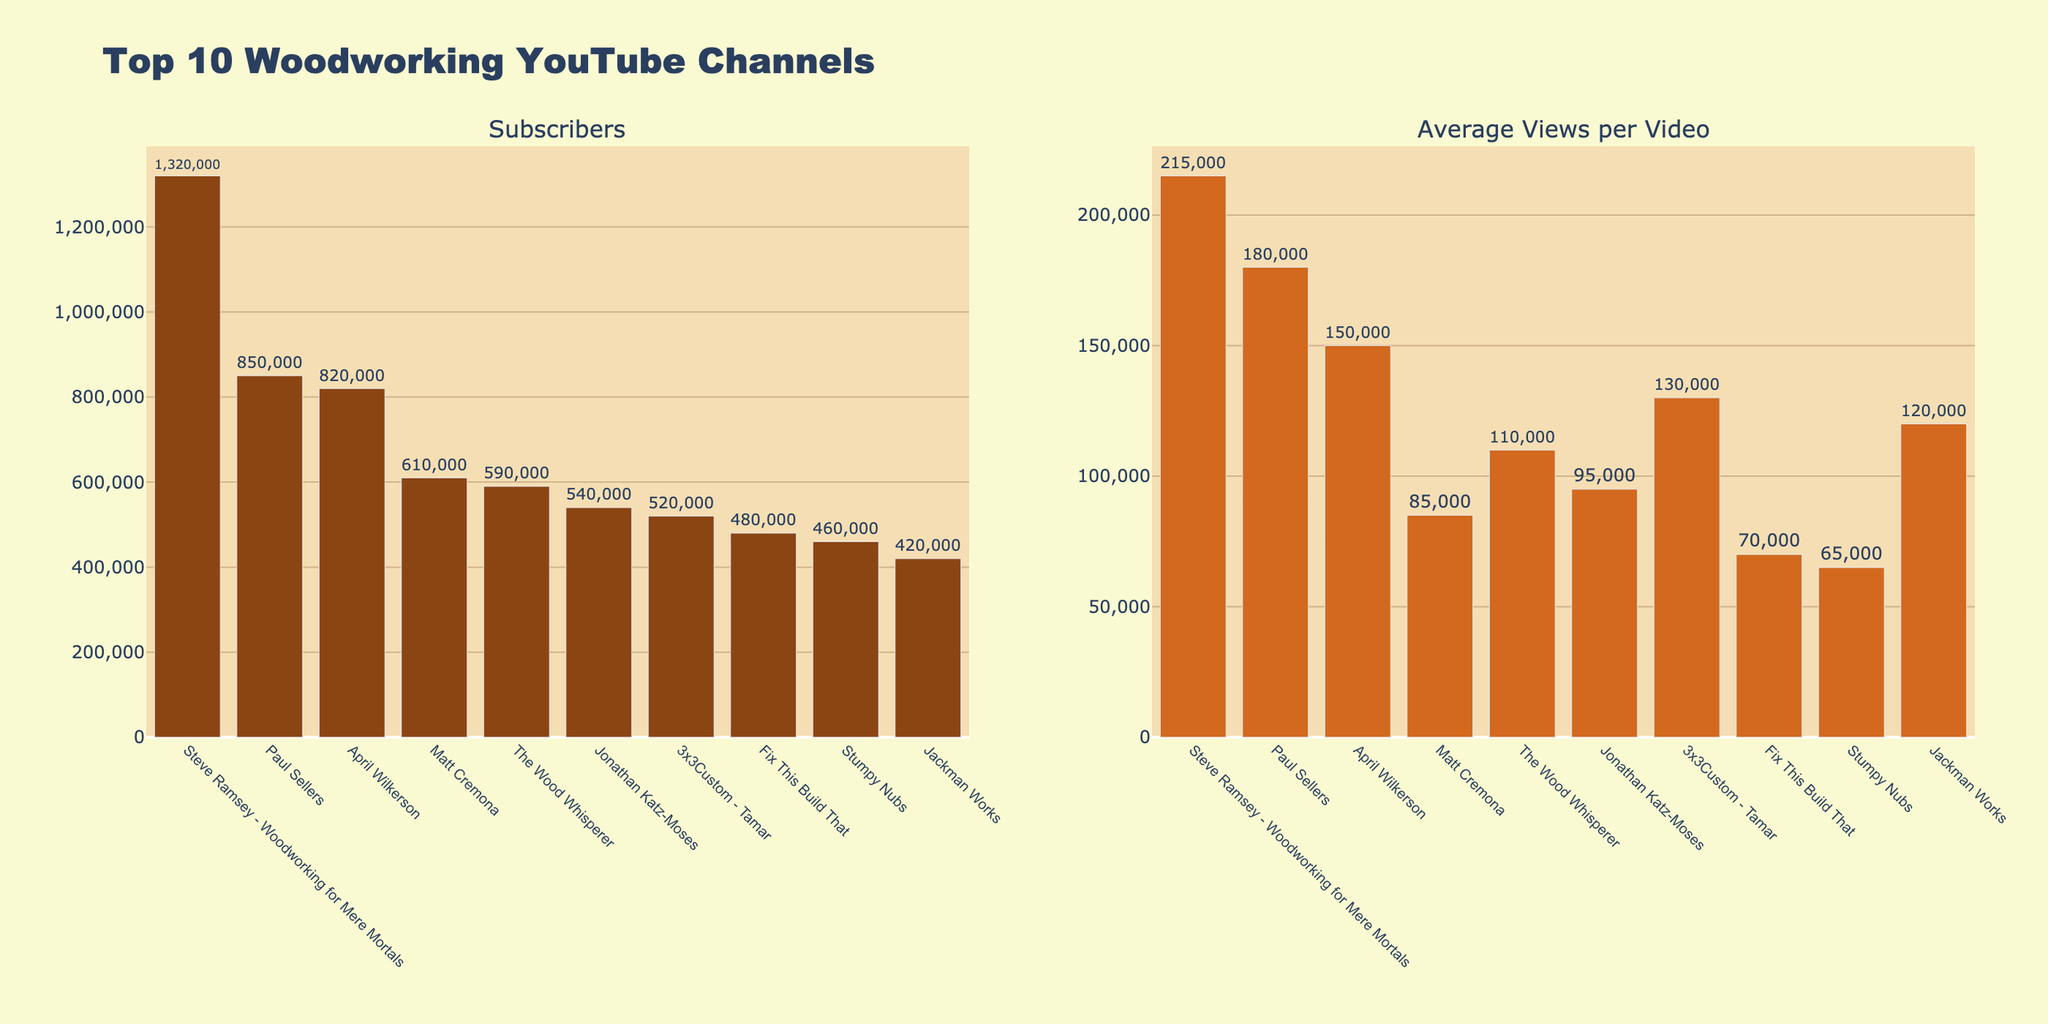What's the total number of subscribers for all top 10 woodworking YouTube channels combined? To find the total number of subscribers, sum the subscriber counts for each channel: 1,320,000 + 850,000 + 820,000 + 610,000 + 590,000 + 540,000 + 520,000 + 480,000 + 460,000 + 420,000 = 6,610,000.
Answer: 6,610,000 Which channel has the highest average views per video? The channel with the highest bar in the "Average Views per Video" subplot corresponds to Steve Ramsey - Woodworking for Mere Mortals with 215,000 average views per video.
Answer: Steve Ramsey - Woodworking for Mere Mortals How many more subscribers does Steve Ramsey - Woodworking for Mere Mortals have than Paul Sellers? Subtract the number of subscribers of Paul Sellers from that of Steve Ramsey - Woodworking for Mere Mortals: 1,320,000 - 850,000 = 470,000.
Answer: 470,000 Which channel has a greater number of subscribers: The Wood Whisperer or Matt Cremona? Compare the subscriber counts shown on their respective bars in the "Subscribers" subplot. The Wood Whisperer has 590,000 subscribers and Matt Cremona has 610,000 subscribers.
Answer: Matt Cremona What is the average number of views per video for the bottom five channels in the list? Sum the average views per video for the bottom five channels and divide by 5: (110,000 + 95,000 + 130,000 + 70,000 + 65,000) / 5 = 94,000.
Answer: 94,000 Identify the two channels with the closest average views per video and specify the difference. Look for channels with similar average views per video by comparing bar heights. Paul Sellers has 180,000 and April Wilkerson has 150,000, so the difference is 180,000 - 150,000 = 30,000.
Answer: Paul Sellers and April Wilkerson, 30,000 Which channel has the smallest number of subscribers? The channel with the shortest bar in the "Subscribers" subplot corresponds to Jackman Works with 420,000 subscribers.
Answer: Jackman Works If you sum the average views per video for the top three channels by subscribers, what do you get? Sum the average views per video for the top three subscribers: 215,000 (Steve Ramsey - Woodworking for Mere Mortals) + 180,000 (Paul Sellers) + 150,000 (April Wilkerson) = 545,000.
Answer: 545,000 Compare the color of the bars representing subscribers and average views per video. The bars representing subscribers are in shades of brown while the bars representing average views per video are in a different shade of brown.
Answer: Subscribers: darker brown, Avg Views: lighter brown 